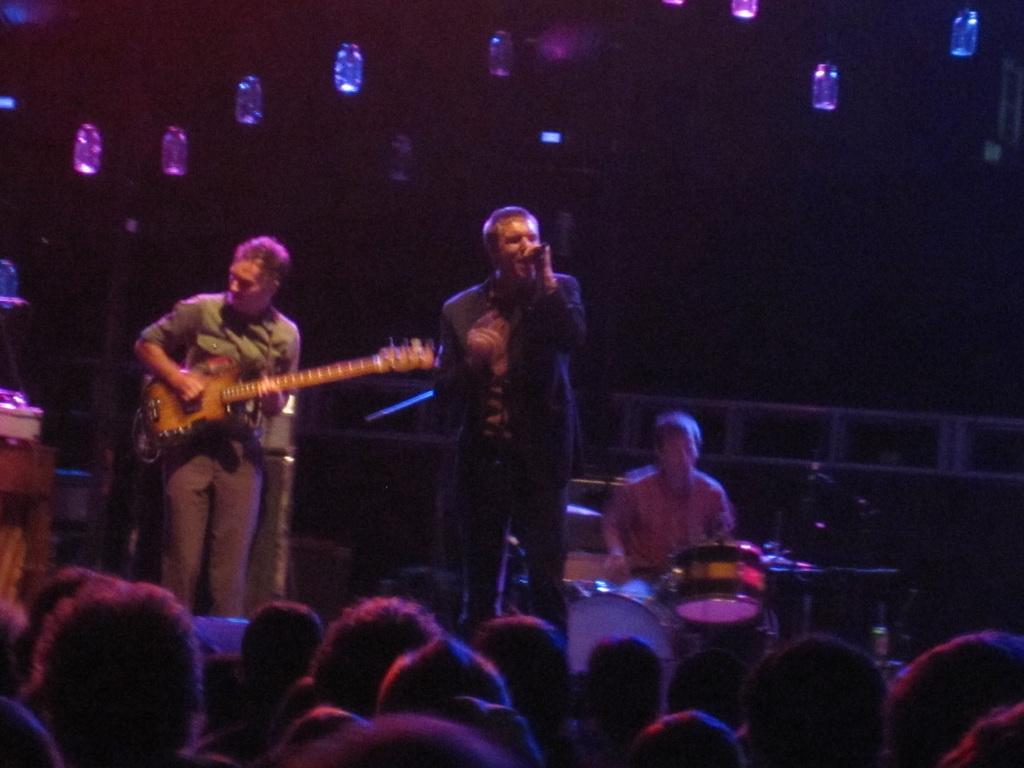Describe this image in one or two sentences. These two persons standing. This person holding guitar. This person holding microphone and singing. This person sitting and playing musical instrument. These are audience. On the top we can see lights. 